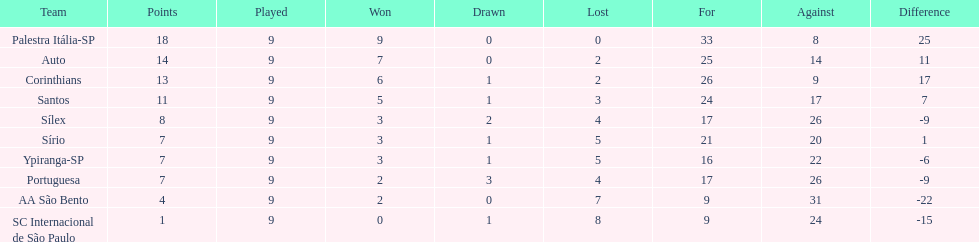What are all the teams? Palestra Itália-SP, Auto, Corinthians, Santos, Sílex, Sírio, Ypiranga-SP, Portuguesa, AA São Bento, SC Internacional de São Paulo. How many times did each team lose? 0, 2, 2, 3, 4, 5, 5, 4, 7, 8. And which team never lost? Palestra Itália-SP. 